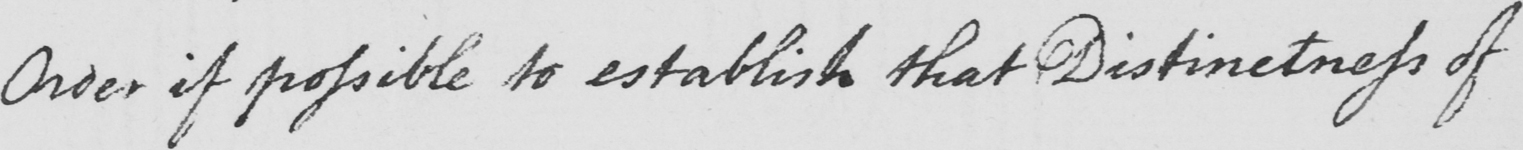Please transcribe the handwritten text in this image. Order if possible to establish that Distinctness of 